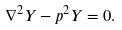<formula> <loc_0><loc_0><loc_500><loc_500>\nabla ^ { 2 } Y - p ^ { 2 } Y = 0 .</formula> 